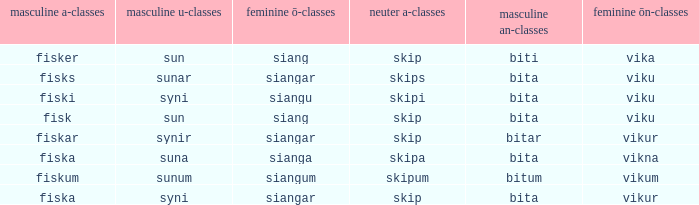What is the masculine u form for the old Swedish word with a neuter a form of skipum? Sunum. 